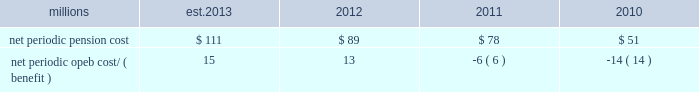The table presents the net periodic pension and opeb cost/ ( benefit ) for the years ended december 31 : millions 2013 2012 2011 2010 .
Our net periodic pension cost is expected to increase to approximately $ 111 million in 2013 from $ 89 million in 2012 .
The increase is driven mainly by a decrease in the discount rate to 3.78% ( 3.78 % ) , our net periodic opeb expense is expected to increase to approximately $ 15 million in 2013 from $ 13 million in 2012 .
The increase in our net periodic opeb cost is primarily driven by a decrease in the discount rate to 3.48% ( 3.48 % ) .
Cautionary information certain statements in this report , and statements in other reports or information filed or to be filed with the sec ( as well as information included in oral statements or other written statements made or to be made by us ) , are , or will be , forward-looking statements as defined by the securities act of 1933 and the securities exchange act of 1934 .
These forward-looking statements and information include , without limitation , ( a ) statements in the ceo 2019s letter preceding part i ; statements regarding planned capital expenditures under the caption 201c2013 capital expenditures 201d in item 2 of part i ; statements regarding dividends in item 5 ; and statements and information set forth under the captions 201c2013 outlook 201d and 201cliquidity and capital resources 201d in this item 7 , and ( b ) any other statements or information in this report ( including information incorporated herein by reference ) regarding : expectations as to financial performance , revenue growth and cost savings ; the time by which goals , targets , or objectives will be achieved ; projections , predictions , expectations , estimates , or forecasts as to our business , financial and operational results , future economic performance , and general economic conditions ; expectations as to operational or service performance or improvements ; expectations as to the effectiveness of steps taken or to be taken to improve operations and/or service , including capital expenditures for infrastructure improvements and equipment acquisitions , any strategic business acquisitions , and modifications to our transportation plans ( including statements set forth in item 2 as to expectations related to our planned capital expenditures ) ; expectations as to existing or proposed new products and services ; expectations as to the impact of any new regulatory activities or legislation on our operations or financial results ; estimates of costs relating to environmental remediation and restoration ; estimates and expectations regarding tax matters ; expectations that claims , litigation , environmental costs , commitments , contingent liabilities , labor negotiations or agreements , or other matters will not have a material adverse effect on our consolidated results of operations , financial condition , or liquidity and any other similar expressions concerning matters that are not historical facts .
Forward-looking statements may be identified by their use of forward-looking terminology , such as 201cbelieves , 201d 201cexpects , 201d 201cmay , 201d 201cshould , 201d 201cwould , 201d 201cwill , 201d 201cintends , 201d 201cplans , 201d 201cestimates , 201d 201canticipates , 201d 201cprojects 201d and similar words , phrases or expressions .
Forward-looking statements should not be read as a guarantee of future performance or results , and will not necessarily be accurate indications of the times that , or by which , such performance or results will be achieved .
Forward-looking statements and information are subject to risks and uncertainties that could cause actual performance or results to differ materially from those expressed in the statements and information .
Forward-looking statements and information reflect the good faith consideration by management of currently available information , and may be based on underlying assumptions believed to be reasonable under the circumstances .
However , such information and assumptions ( and , therefore , such forward-looking statements and information ) are or may be subject to variables or unknown or unforeseeable events or circumstances over which management has little or no influence or control .
The risk factors in item 1a of this report could affect our future results and could cause those results or other outcomes to differ materially from those expressed or implied in any forward-looking statements or information .
To the extent circumstances require or we deem it otherwise necessary , we will update or amend these risk factors in a form 10-q , form 8-k or subsequent form 10-k .
All forward-looking statements are qualified by , and should be read in conjunction with , these risk factors .
Forward-looking statements speak only as of the date the statement was made .
We assume no obligation to update forward-looking information to reflect actual results , changes in assumptions or changes in other factors affecting forward-looking information .
If we do update one or more forward-looking .
If 2012 net periodic opeb cost increased at the same pace as the pension cost , what would the estimated 2013 cost be in millions? 
Computations: ((89 / 78) * 13)
Answer: 14.83333. 